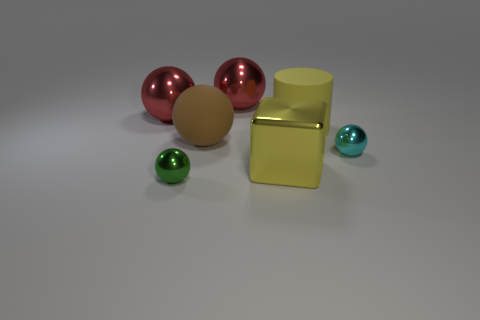There is a rubber thing that is the same shape as the cyan metallic object; what color is it? The rubber object that shares the same spherical shape as the cyan metallic ball is actually beige in color, providing a soft visual contrast to the more vivid metallic shades present in the image. 